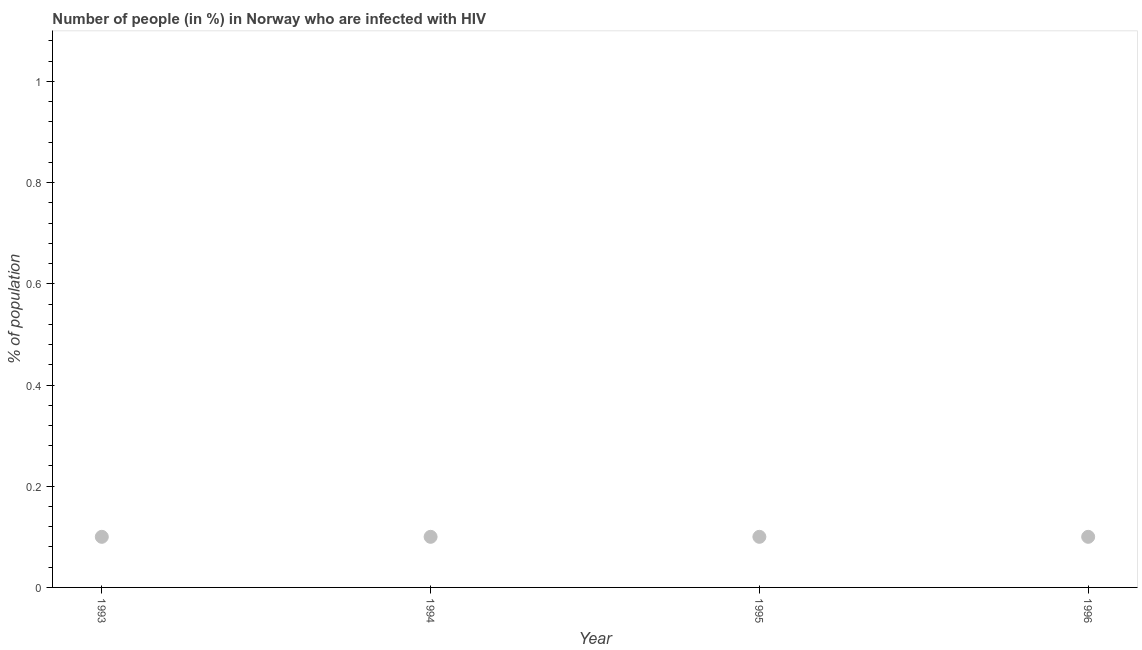What is the number of people infected with hiv in 1994?
Keep it short and to the point. 0.1. Across all years, what is the maximum number of people infected with hiv?
Offer a terse response. 0.1. Across all years, what is the minimum number of people infected with hiv?
Provide a succinct answer. 0.1. In which year was the number of people infected with hiv minimum?
Keep it short and to the point. 1993. What is the sum of the number of people infected with hiv?
Your answer should be compact. 0.4. What is the difference between the number of people infected with hiv in 1994 and 1995?
Your answer should be compact. 0. In how many years, is the number of people infected with hiv greater than 0.8400000000000001 %?
Make the answer very short. 0. Do a majority of the years between 1996 and 1995 (inclusive) have number of people infected with hiv greater than 0.32 %?
Give a very brief answer. No. Is the difference between the number of people infected with hiv in 1993 and 1994 greater than the difference between any two years?
Your response must be concise. Yes. What is the difference between the highest and the lowest number of people infected with hiv?
Give a very brief answer. 0. Does the number of people infected with hiv monotonically increase over the years?
Give a very brief answer. No. What is the difference between two consecutive major ticks on the Y-axis?
Give a very brief answer. 0.2. Are the values on the major ticks of Y-axis written in scientific E-notation?
Your answer should be compact. No. Does the graph contain any zero values?
Offer a very short reply. No. What is the title of the graph?
Your answer should be very brief. Number of people (in %) in Norway who are infected with HIV. What is the label or title of the Y-axis?
Provide a short and direct response. % of population. What is the % of population in 1995?
Ensure brevity in your answer.  0.1. What is the % of population in 1996?
Your answer should be compact. 0.1. What is the difference between the % of population in 1993 and 1994?
Ensure brevity in your answer.  0. What is the difference between the % of population in 1993 and 1995?
Your answer should be compact. 0. What is the difference between the % of population in 1993 and 1996?
Make the answer very short. 0. What is the difference between the % of population in 1994 and 1995?
Your answer should be very brief. 0. What is the difference between the % of population in 1994 and 1996?
Ensure brevity in your answer.  0. What is the ratio of the % of population in 1993 to that in 1994?
Offer a terse response. 1. What is the ratio of the % of population in 1995 to that in 1996?
Offer a terse response. 1. 